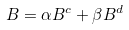Convert formula to latex. <formula><loc_0><loc_0><loc_500><loc_500>B = \alpha B ^ { c } + \beta B ^ { d }</formula> 